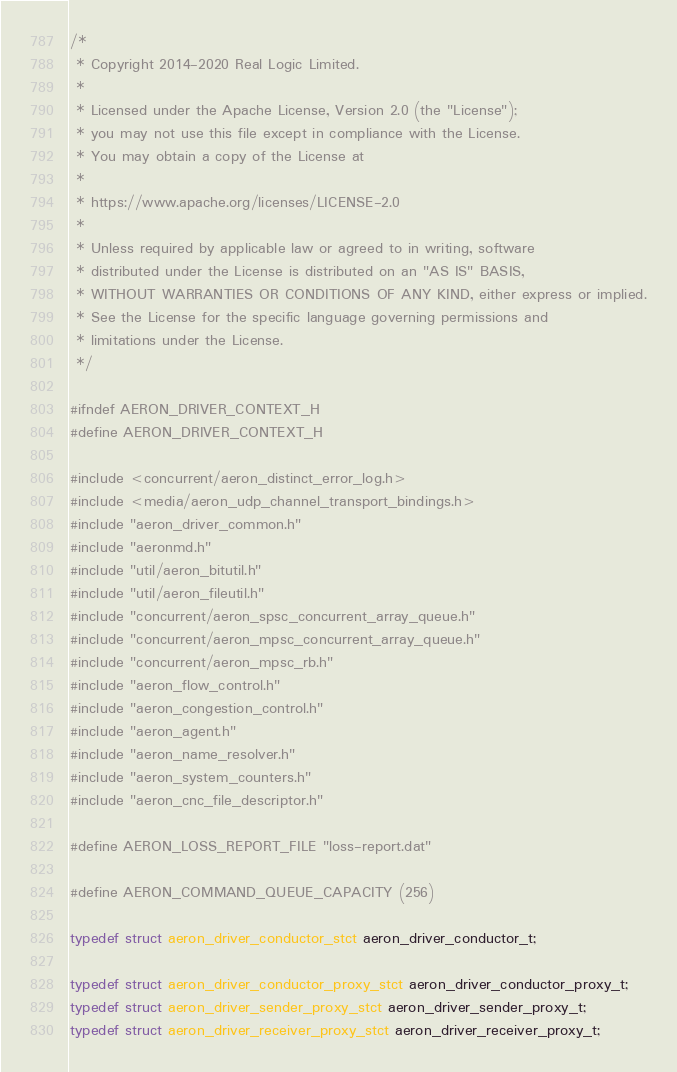Convert code to text. <code><loc_0><loc_0><loc_500><loc_500><_C_>/*
 * Copyright 2014-2020 Real Logic Limited.
 *
 * Licensed under the Apache License, Version 2.0 (the "License");
 * you may not use this file except in compliance with the License.
 * You may obtain a copy of the License at
 *
 * https://www.apache.org/licenses/LICENSE-2.0
 *
 * Unless required by applicable law or agreed to in writing, software
 * distributed under the License is distributed on an "AS IS" BASIS,
 * WITHOUT WARRANTIES OR CONDITIONS OF ANY KIND, either express or implied.
 * See the License for the specific language governing permissions and
 * limitations under the License.
 */

#ifndef AERON_DRIVER_CONTEXT_H
#define AERON_DRIVER_CONTEXT_H

#include <concurrent/aeron_distinct_error_log.h>
#include <media/aeron_udp_channel_transport_bindings.h>
#include "aeron_driver_common.h"
#include "aeronmd.h"
#include "util/aeron_bitutil.h"
#include "util/aeron_fileutil.h"
#include "concurrent/aeron_spsc_concurrent_array_queue.h"
#include "concurrent/aeron_mpsc_concurrent_array_queue.h"
#include "concurrent/aeron_mpsc_rb.h"
#include "aeron_flow_control.h"
#include "aeron_congestion_control.h"
#include "aeron_agent.h"
#include "aeron_name_resolver.h"
#include "aeron_system_counters.h"
#include "aeron_cnc_file_descriptor.h"

#define AERON_LOSS_REPORT_FILE "loss-report.dat"

#define AERON_COMMAND_QUEUE_CAPACITY (256)

typedef struct aeron_driver_conductor_stct aeron_driver_conductor_t;

typedef struct aeron_driver_conductor_proxy_stct aeron_driver_conductor_proxy_t;
typedef struct aeron_driver_sender_proxy_stct aeron_driver_sender_proxy_t;
typedef struct aeron_driver_receiver_proxy_stct aeron_driver_receiver_proxy_t;
</code> 